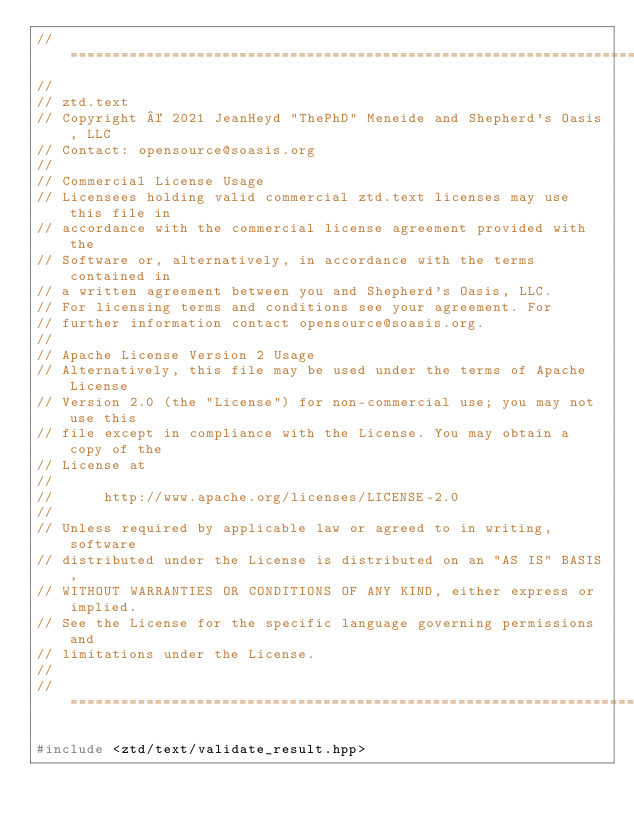<code> <loc_0><loc_0><loc_500><loc_500><_C++_>// =============================================================================
//
// ztd.text
// Copyright © 2021 JeanHeyd "ThePhD" Meneide and Shepherd's Oasis, LLC
// Contact: opensource@soasis.org
//
// Commercial License Usage
// Licensees holding valid commercial ztd.text licenses may use this file in
// accordance with the commercial license agreement provided with the
// Software or, alternatively, in accordance with the terms contained in
// a written agreement between you and Shepherd's Oasis, LLC.
// For licensing terms and conditions see your agreement. For
// further information contact opensource@soasis.org.
//
// Apache License Version 2 Usage
// Alternatively, this file may be used under the terms of Apache License
// Version 2.0 (the "License") for non-commercial use; you may not use this
// file except in compliance with the License. You may obtain a copy of the 
// License at
//
//		http://www.apache.org/licenses/LICENSE-2.0
//
// Unless required by applicable law or agreed to in writing, software
// distributed under the License is distributed on an "AS IS" BASIS,
// WITHOUT WARRANTIES OR CONDITIONS OF ANY KIND, either express or implied.
// See the License for the specific language governing permissions and
// limitations under the License.
//
// ============================================================================>

#include <ztd/text/validate_result.hpp>
</code> 